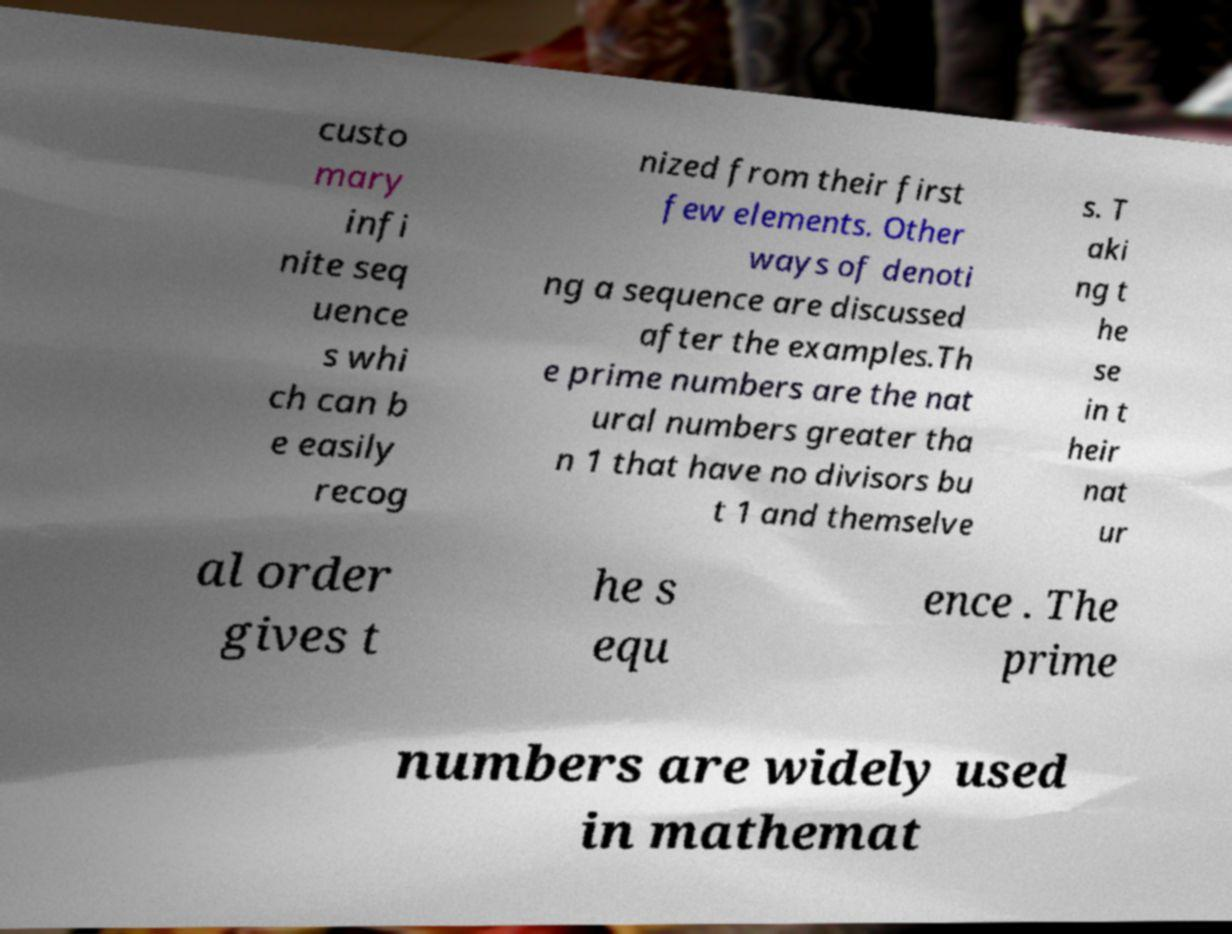Can you read and provide the text displayed in the image?This photo seems to have some interesting text. Can you extract and type it out for me? custo mary infi nite seq uence s whi ch can b e easily recog nized from their first few elements. Other ways of denoti ng a sequence are discussed after the examples.Th e prime numbers are the nat ural numbers greater tha n 1 that have no divisors bu t 1 and themselve s. T aki ng t he se in t heir nat ur al order gives t he s equ ence . The prime numbers are widely used in mathemat 